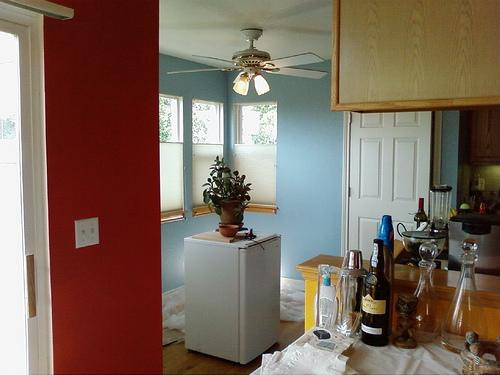What is sitting on the mini fridge in the center of the room? plant 